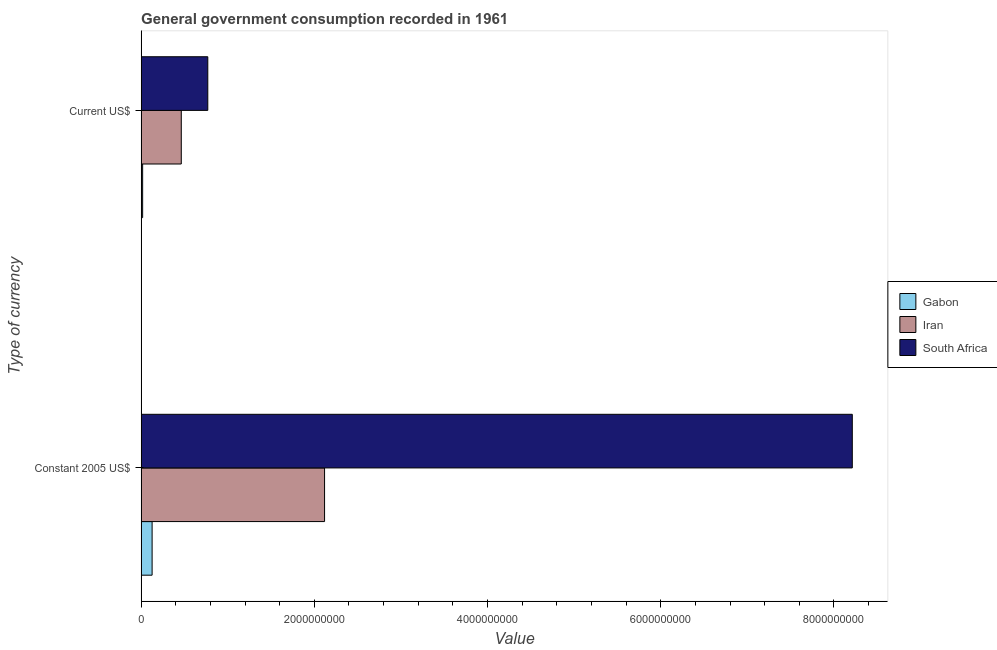How many groups of bars are there?
Give a very brief answer. 2. How many bars are there on the 2nd tick from the top?
Provide a short and direct response. 3. How many bars are there on the 1st tick from the bottom?
Offer a terse response. 3. What is the label of the 2nd group of bars from the top?
Make the answer very short. Constant 2005 US$. What is the value consumed in current us$ in Gabon?
Your response must be concise. 1.72e+07. Across all countries, what is the maximum value consumed in constant 2005 us$?
Offer a terse response. 8.21e+09. Across all countries, what is the minimum value consumed in current us$?
Offer a very short reply. 1.72e+07. In which country was the value consumed in current us$ maximum?
Make the answer very short. South Africa. In which country was the value consumed in current us$ minimum?
Ensure brevity in your answer.  Gabon. What is the total value consumed in current us$ in the graph?
Keep it short and to the point. 1.25e+09. What is the difference between the value consumed in current us$ in Gabon and that in Iran?
Keep it short and to the point. -4.46e+08. What is the difference between the value consumed in constant 2005 us$ in South Africa and the value consumed in current us$ in Iran?
Provide a succinct answer. 7.75e+09. What is the average value consumed in current us$ per country?
Provide a succinct answer. 4.17e+08. What is the difference between the value consumed in current us$ and value consumed in constant 2005 us$ in Iran?
Keep it short and to the point. -1.65e+09. In how many countries, is the value consumed in constant 2005 us$ greater than 7200000000 ?
Ensure brevity in your answer.  1. What is the ratio of the value consumed in constant 2005 us$ in South Africa to that in Iran?
Make the answer very short. 3.88. Is the value consumed in current us$ in Iran less than that in Gabon?
Provide a succinct answer. No. What does the 3rd bar from the top in Constant 2005 US$ represents?
Your response must be concise. Gabon. What does the 3rd bar from the bottom in Current US$ represents?
Give a very brief answer. South Africa. How many countries are there in the graph?
Ensure brevity in your answer.  3. Are the values on the major ticks of X-axis written in scientific E-notation?
Your response must be concise. No. Does the graph contain any zero values?
Make the answer very short. No. Does the graph contain grids?
Your response must be concise. No. Where does the legend appear in the graph?
Your answer should be compact. Center right. How many legend labels are there?
Your answer should be compact. 3. How are the legend labels stacked?
Ensure brevity in your answer.  Vertical. What is the title of the graph?
Provide a succinct answer. General government consumption recorded in 1961. What is the label or title of the X-axis?
Ensure brevity in your answer.  Value. What is the label or title of the Y-axis?
Provide a succinct answer. Type of currency. What is the Value in Gabon in Constant 2005 US$?
Give a very brief answer. 1.27e+08. What is the Value in Iran in Constant 2005 US$?
Provide a succinct answer. 2.12e+09. What is the Value in South Africa in Constant 2005 US$?
Keep it short and to the point. 8.21e+09. What is the Value of Gabon in Current US$?
Offer a terse response. 1.72e+07. What is the Value in Iran in Current US$?
Provide a short and direct response. 4.63e+08. What is the Value in South Africa in Current US$?
Provide a succinct answer. 7.70e+08. Across all Type of currency, what is the maximum Value of Gabon?
Your response must be concise. 1.27e+08. Across all Type of currency, what is the maximum Value of Iran?
Make the answer very short. 2.12e+09. Across all Type of currency, what is the maximum Value in South Africa?
Your response must be concise. 8.21e+09. Across all Type of currency, what is the minimum Value in Gabon?
Your answer should be compact. 1.72e+07. Across all Type of currency, what is the minimum Value of Iran?
Provide a short and direct response. 4.63e+08. Across all Type of currency, what is the minimum Value of South Africa?
Offer a very short reply. 7.70e+08. What is the total Value of Gabon in the graph?
Provide a succinct answer. 1.44e+08. What is the total Value in Iran in the graph?
Provide a succinct answer. 2.58e+09. What is the total Value in South Africa in the graph?
Provide a short and direct response. 8.98e+09. What is the difference between the Value of Gabon in Constant 2005 US$ and that in Current US$?
Offer a terse response. 1.09e+08. What is the difference between the Value in Iran in Constant 2005 US$ and that in Current US$?
Offer a terse response. 1.65e+09. What is the difference between the Value of South Africa in Constant 2005 US$ and that in Current US$?
Make the answer very short. 7.44e+09. What is the difference between the Value of Gabon in Constant 2005 US$ and the Value of Iran in Current US$?
Provide a succinct answer. -3.37e+08. What is the difference between the Value in Gabon in Constant 2005 US$ and the Value in South Africa in Current US$?
Make the answer very short. -6.43e+08. What is the difference between the Value in Iran in Constant 2005 US$ and the Value in South Africa in Current US$?
Keep it short and to the point. 1.35e+09. What is the average Value of Gabon per Type of currency?
Keep it short and to the point. 7.19e+07. What is the average Value in Iran per Type of currency?
Provide a short and direct response. 1.29e+09. What is the average Value in South Africa per Type of currency?
Offer a terse response. 4.49e+09. What is the difference between the Value of Gabon and Value of Iran in Constant 2005 US$?
Ensure brevity in your answer.  -1.99e+09. What is the difference between the Value of Gabon and Value of South Africa in Constant 2005 US$?
Offer a terse response. -8.09e+09. What is the difference between the Value of Iran and Value of South Africa in Constant 2005 US$?
Your answer should be very brief. -6.09e+09. What is the difference between the Value of Gabon and Value of Iran in Current US$?
Keep it short and to the point. -4.46e+08. What is the difference between the Value in Gabon and Value in South Africa in Current US$?
Offer a terse response. -7.52e+08. What is the difference between the Value in Iran and Value in South Africa in Current US$?
Offer a very short reply. -3.06e+08. What is the ratio of the Value in Gabon in Constant 2005 US$ to that in Current US$?
Make the answer very short. 7.35. What is the ratio of the Value in Iran in Constant 2005 US$ to that in Current US$?
Offer a terse response. 4.57. What is the ratio of the Value of South Africa in Constant 2005 US$ to that in Current US$?
Offer a very short reply. 10.67. What is the difference between the highest and the second highest Value in Gabon?
Your answer should be very brief. 1.09e+08. What is the difference between the highest and the second highest Value of Iran?
Your answer should be very brief. 1.65e+09. What is the difference between the highest and the second highest Value of South Africa?
Your response must be concise. 7.44e+09. What is the difference between the highest and the lowest Value in Gabon?
Your response must be concise. 1.09e+08. What is the difference between the highest and the lowest Value in Iran?
Offer a very short reply. 1.65e+09. What is the difference between the highest and the lowest Value in South Africa?
Keep it short and to the point. 7.44e+09. 